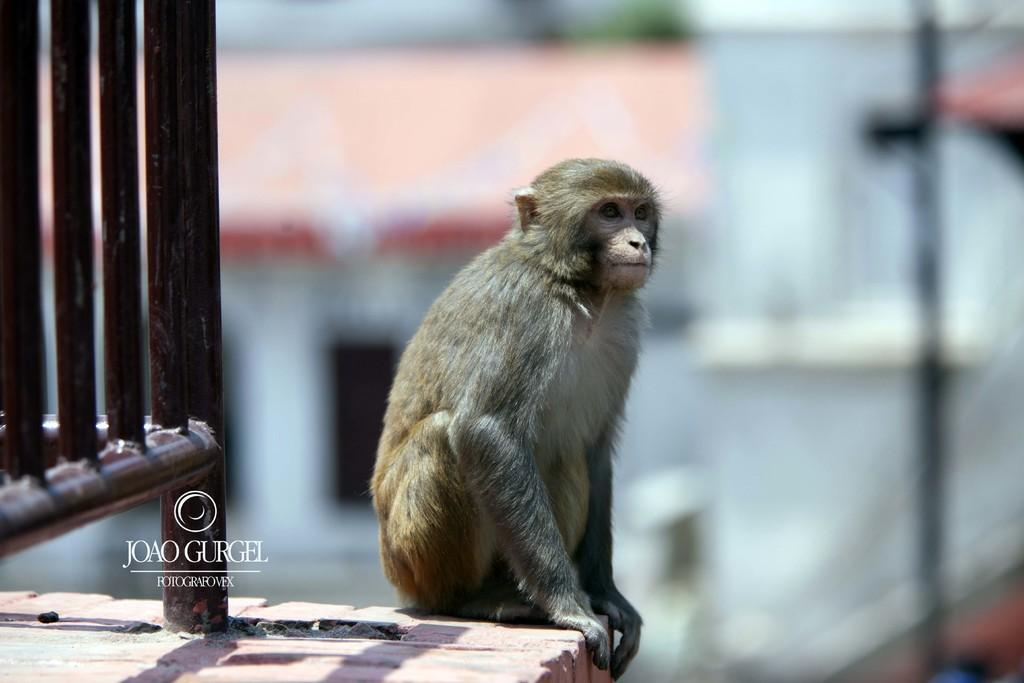What animal is present in the image? There is a monkey in the image. Where is the monkey located? The monkey is on a surface. What can be seen on the left side of the image? There is fencing on the left side of the image. How would you describe the background of the image? The background of the image is blurred. Is the monkey using a spade to dig in the image? There is no spade present in the image, and the monkey is not shown digging. 